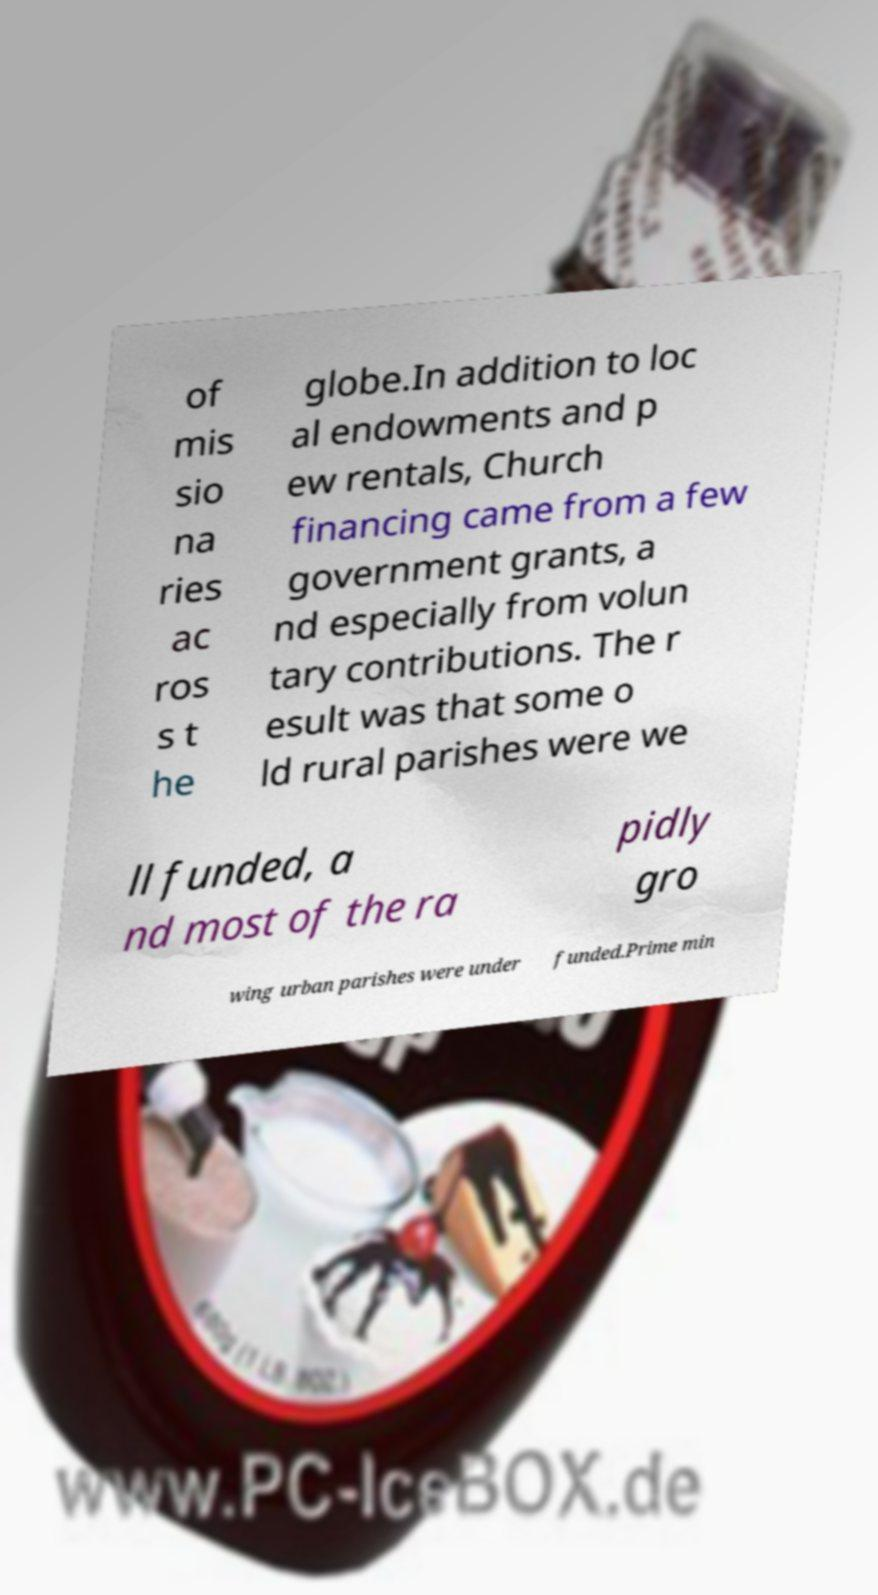There's text embedded in this image that I need extracted. Can you transcribe it verbatim? of mis sio na ries ac ros s t he globe.In addition to loc al endowments and p ew rentals, Church financing came from a few government grants, a nd especially from volun tary contributions. The r esult was that some o ld rural parishes were we ll funded, a nd most of the ra pidly gro wing urban parishes were under funded.Prime min 